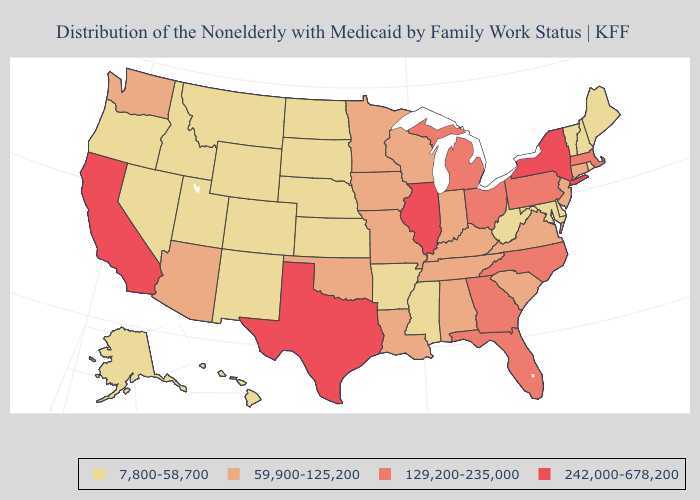Among the states that border New Mexico , which have the highest value?
Be succinct. Texas. Does the first symbol in the legend represent the smallest category?
Concise answer only. Yes. Name the states that have a value in the range 242,000-678,200?
Write a very short answer. California, Illinois, New York, Texas. Name the states that have a value in the range 242,000-678,200?
Keep it brief. California, Illinois, New York, Texas. Which states have the lowest value in the USA?
Concise answer only. Alaska, Arkansas, Colorado, Delaware, Hawaii, Idaho, Kansas, Maine, Maryland, Mississippi, Montana, Nebraska, Nevada, New Hampshire, New Mexico, North Dakota, Oregon, Rhode Island, South Dakota, Utah, Vermont, West Virginia, Wyoming. How many symbols are there in the legend?
Give a very brief answer. 4. Which states have the lowest value in the MidWest?
Write a very short answer. Kansas, Nebraska, North Dakota, South Dakota. What is the value of California?
Concise answer only. 242,000-678,200. Does Michigan have the highest value in the USA?
Give a very brief answer. No. What is the value of Washington?
Short answer required. 59,900-125,200. Among the states that border Connecticut , does Rhode Island have the lowest value?
Answer briefly. Yes. Does Connecticut have a higher value than Utah?
Give a very brief answer. Yes. Name the states that have a value in the range 242,000-678,200?
Quick response, please. California, Illinois, New York, Texas. Does the first symbol in the legend represent the smallest category?
Answer briefly. Yes. 